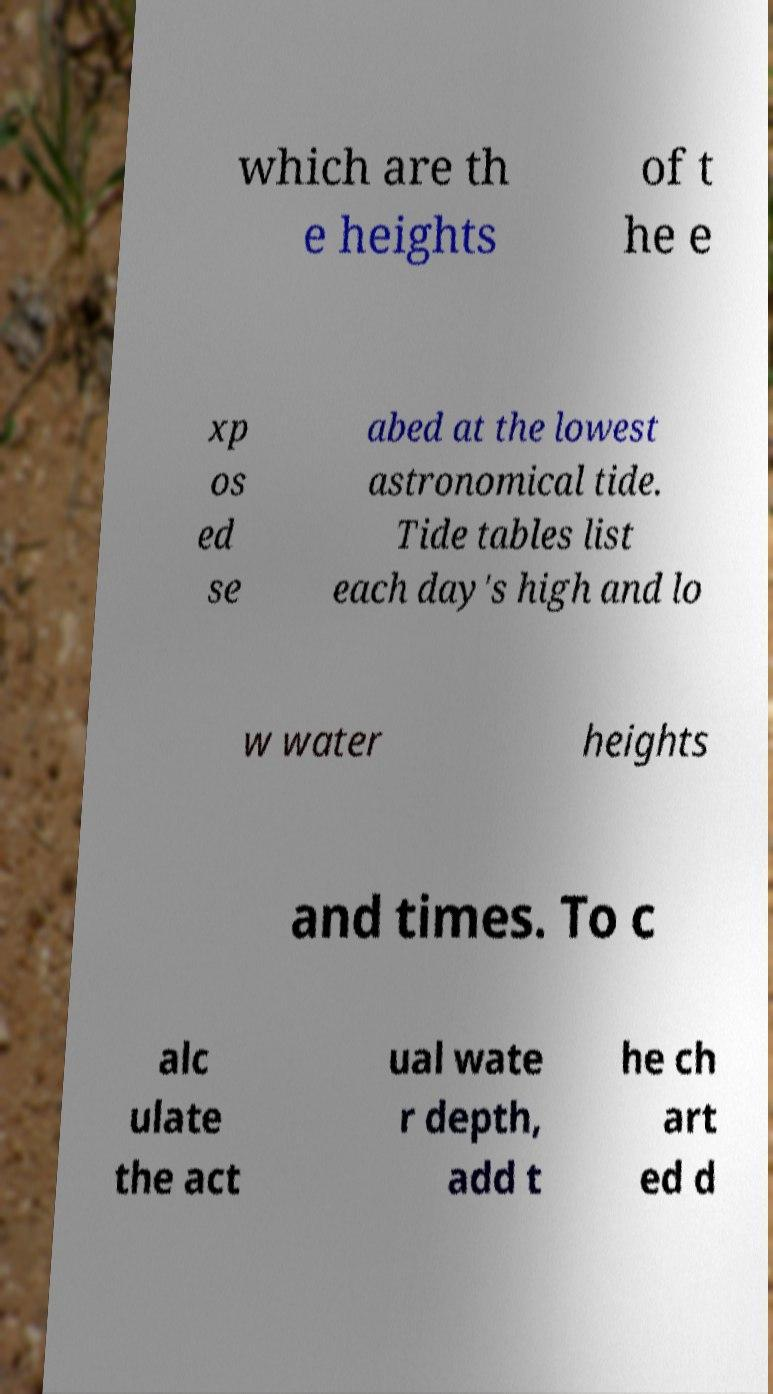Please identify and transcribe the text found in this image. which are th e heights of t he e xp os ed se abed at the lowest astronomical tide. Tide tables list each day's high and lo w water heights and times. To c alc ulate the act ual wate r depth, add t he ch art ed d 